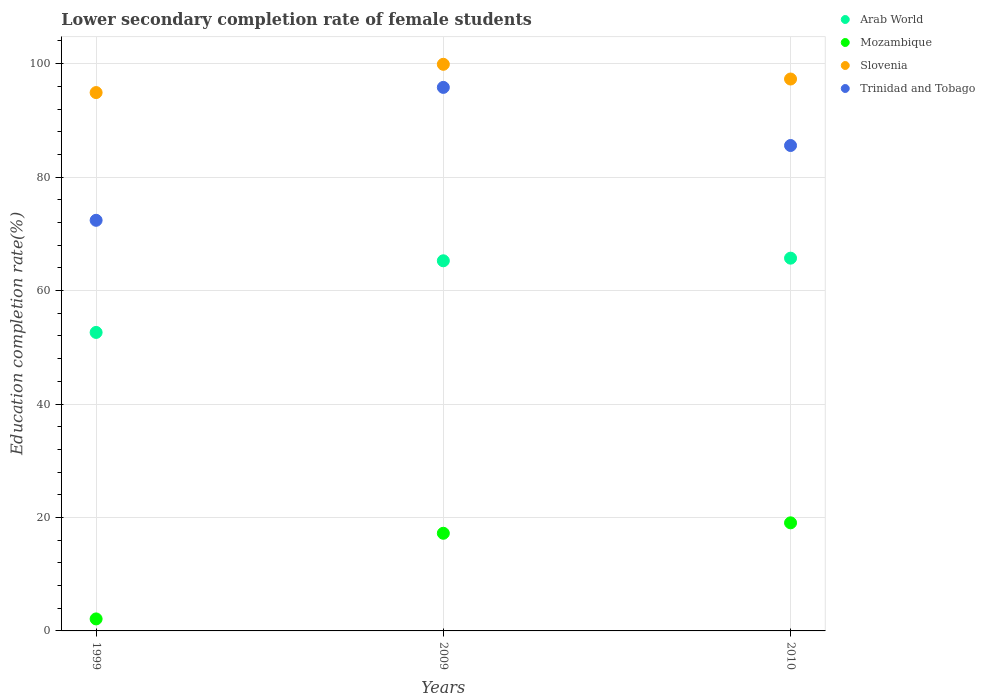How many different coloured dotlines are there?
Provide a succinct answer. 4. What is the lower secondary completion rate of female students in Slovenia in 1999?
Provide a succinct answer. 94.9. Across all years, what is the maximum lower secondary completion rate of female students in Arab World?
Provide a succinct answer. 65.71. Across all years, what is the minimum lower secondary completion rate of female students in Mozambique?
Ensure brevity in your answer.  2.12. In which year was the lower secondary completion rate of female students in Trinidad and Tobago minimum?
Offer a very short reply. 1999. What is the total lower secondary completion rate of female students in Arab World in the graph?
Provide a short and direct response. 183.58. What is the difference between the lower secondary completion rate of female students in Slovenia in 1999 and that in 2009?
Your response must be concise. -4.98. What is the difference between the lower secondary completion rate of female students in Trinidad and Tobago in 1999 and the lower secondary completion rate of female students in Mozambique in 2009?
Keep it short and to the point. 55.17. What is the average lower secondary completion rate of female students in Arab World per year?
Your response must be concise. 61.19. In the year 2010, what is the difference between the lower secondary completion rate of female students in Slovenia and lower secondary completion rate of female students in Trinidad and Tobago?
Your answer should be very brief. 11.72. In how many years, is the lower secondary completion rate of female students in Slovenia greater than 56 %?
Your answer should be compact. 3. What is the ratio of the lower secondary completion rate of female students in Arab World in 2009 to that in 2010?
Your answer should be very brief. 0.99. What is the difference between the highest and the second highest lower secondary completion rate of female students in Slovenia?
Offer a terse response. 2.59. What is the difference between the highest and the lowest lower secondary completion rate of female students in Slovenia?
Your answer should be very brief. 4.98. In how many years, is the lower secondary completion rate of female students in Trinidad and Tobago greater than the average lower secondary completion rate of female students in Trinidad and Tobago taken over all years?
Offer a terse response. 2. Is the sum of the lower secondary completion rate of female students in Trinidad and Tobago in 2009 and 2010 greater than the maximum lower secondary completion rate of female students in Arab World across all years?
Give a very brief answer. Yes. Is the lower secondary completion rate of female students in Slovenia strictly less than the lower secondary completion rate of female students in Arab World over the years?
Provide a short and direct response. No. How many years are there in the graph?
Your answer should be very brief. 3. How many legend labels are there?
Provide a succinct answer. 4. How are the legend labels stacked?
Give a very brief answer. Vertical. What is the title of the graph?
Give a very brief answer. Lower secondary completion rate of female students. What is the label or title of the Y-axis?
Your answer should be compact. Education completion rate(%). What is the Education completion rate(%) of Arab World in 1999?
Make the answer very short. 52.62. What is the Education completion rate(%) of Mozambique in 1999?
Offer a terse response. 2.12. What is the Education completion rate(%) in Slovenia in 1999?
Make the answer very short. 94.9. What is the Education completion rate(%) in Trinidad and Tobago in 1999?
Keep it short and to the point. 72.39. What is the Education completion rate(%) in Arab World in 2009?
Your answer should be compact. 65.25. What is the Education completion rate(%) of Mozambique in 2009?
Your answer should be compact. 17.21. What is the Education completion rate(%) of Slovenia in 2009?
Your answer should be very brief. 99.89. What is the Education completion rate(%) of Trinidad and Tobago in 2009?
Offer a terse response. 95.82. What is the Education completion rate(%) in Arab World in 2010?
Offer a very short reply. 65.71. What is the Education completion rate(%) in Mozambique in 2010?
Keep it short and to the point. 19.05. What is the Education completion rate(%) in Slovenia in 2010?
Your response must be concise. 97.29. What is the Education completion rate(%) of Trinidad and Tobago in 2010?
Keep it short and to the point. 85.57. Across all years, what is the maximum Education completion rate(%) of Arab World?
Give a very brief answer. 65.71. Across all years, what is the maximum Education completion rate(%) of Mozambique?
Ensure brevity in your answer.  19.05. Across all years, what is the maximum Education completion rate(%) of Slovenia?
Give a very brief answer. 99.89. Across all years, what is the maximum Education completion rate(%) in Trinidad and Tobago?
Make the answer very short. 95.82. Across all years, what is the minimum Education completion rate(%) in Arab World?
Give a very brief answer. 52.62. Across all years, what is the minimum Education completion rate(%) of Mozambique?
Your answer should be compact. 2.12. Across all years, what is the minimum Education completion rate(%) of Slovenia?
Your answer should be compact. 94.9. Across all years, what is the minimum Education completion rate(%) of Trinidad and Tobago?
Keep it short and to the point. 72.39. What is the total Education completion rate(%) in Arab World in the graph?
Provide a succinct answer. 183.58. What is the total Education completion rate(%) of Mozambique in the graph?
Give a very brief answer. 38.38. What is the total Education completion rate(%) of Slovenia in the graph?
Give a very brief answer. 292.08. What is the total Education completion rate(%) in Trinidad and Tobago in the graph?
Your response must be concise. 253.77. What is the difference between the Education completion rate(%) in Arab World in 1999 and that in 2009?
Give a very brief answer. -12.63. What is the difference between the Education completion rate(%) in Mozambique in 1999 and that in 2009?
Your answer should be compact. -15.1. What is the difference between the Education completion rate(%) in Slovenia in 1999 and that in 2009?
Your answer should be very brief. -4.98. What is the difference between the Education completion rate(%) of Trinidad and Tobago in 1999 and that in 2009?
Your response must be concise. -23.43. What is the difference between the Education completion rate(%) in Arab World in 1999 and that in 2010?
Your response must be concise. -13.09. What is the difference between the Education completion rate(%) in Mozambique in 1999 and that in 2010?
Make the answer very short. -16.94. What is the difference between the Education completion rate(%) of Slovenia in 1999 and that in 2010?
Ensure brevity in your answer.  -2.39. What is the difference between the Education completion rate(%) of Trinidad and Tobago in 1999 and that in 2010?
Your answer should be very brief. -13.19. What is the difference between the Education completion rate(%) of Arab World in 2009 and that in 2010?
Your answer should be compact. -0.46. What is the difference between the Education completion rate(%) of Mozambique in 2009 and that in 2010?
Provide a succinct answer. -1.84. What is the difference between the Education completion rate(%) in Slovenia in 2009 and that in 2010?
Give a very brief answer. 2.59. What is the difference between the Education completion rate(%) in Trinidad and Tobago in 2009 and that in 2010?
Your answer should be very brief. 10.24. What is the difference between the Education completion rate(%) in Arab World in 1999 and the Education completion rate(%) in Mozambique in 2009?
Keep it short and to the point. 35.41. What is the difference between the Education completion rate(%) in Arab World in 1999 and the Education completion rate(%) in Slovenia in 2009?
Your answer should be very brief. -47.27. What is the difference between the Education completion rate(%) in Arab World in 1999 and the Education completion rate(%) in Trinidad and Tobago in 2009?
Ensure brevity in your answer.  -43.2. What is the difference between the Education completion rate(%) of Mozambique in 1999 and the Education completion rate(%) of Slovenia in 2009?
Keep it short and to the point. -97.77. What is the difference between the Education completion rate(%) in Mozambique in 1999 and the Education completion rate(%) in Trinidad and Tobago in 2009?
Offer a terse response. -93.7. What is the difference between the Education completion rate(%) in Slovenia in 1999 and the Education completion rate(%) in Trinidad and Tobago in 2009?
Provide a short and direct response. -0.91. What is the difference between the Education completion rate(%) in Arab World in 1999 and the Education completion rate(%) in Mozambique in 2010?
Offer a terse response. 33.57. What is the difference between the Education completion rate(%) of Arab World in 1999 and the Education completion rate(%) of Slovenia in 2010?
Give a very brief answer. -44.67. What is the difference between the Education completion rate(%) in Arab World in 1999 and the Education completion rate(%) in Trinidad and Tobago in 2010?
Ensure brevity in your answer.  -32.95. What is the difference between the Education completion rate(%) of Mozambique in 1999 and the Education completion rate(%) of Slovenia in 2010?
Offer a very short reply. -95.17. What is the difference between the Education completion rate(%) in Mozambique in 1999 and the Education completion rate(%) in Trinidad and Tobago in 2010?
Give a very brief answer. -83.45. What is the difference between the Education completion rate(%) in Slovenia in 1999 and the Education completion rate(%) in Trinidad and Tobago in 2010?
Provide a short and direct response. 9.33. What is the difference between the Education completion rate(%) of Arab World in 2009 and the Education completion rate(%) of Mozambique in 2010?
Your answer should be very brief. 46.2. What is the difference between the Education completion rate(%) of Arab World in 2009 and the Education completion rate(%) of Slovenia in 2010?
Your response must be concise. -32.04. What is the difference between the Education completion rate(%) in Arab World in 2009 and the Education completion rate(%) in Trinidad and Tobago in 2010?
Ensure brevity in your answer.  -20.32. What is the difference between the Education completion rate(%) of Mozambique in 2009 and the Education completion rate(%) of Slovenia in 2010?
Your response must be concise. -80.08. What is the difference between the Education completion rate(%) of Mozambique in 2009 and the Education completion rate(%) of Trinidad and Tobago in 2010?
Offer a very short reply. -68.36. What is the difference between the Education completion rate(%) of Slovenia in 2009 and the Education completion rate(%) of Trinidad and Tobago in 2010?
Offer a very short reply. 14.32. What is the average Education completion rate(%) in Arab World per year?
Your answer should be compact. 61.19. What is the average Education completion rate(%) in Mozambique per year?
Offer a very short reply. 12.79. What is the average Education completion rate(%) of Slovenia per year?
Offer a very short reply. 97.36. What is the average Education completion rate(%) in Trinidad and Tobago per year?
Provide a succinct answer. 84.59. In the year 1999, what is the difference between the Education completion rate(%) in Arab World and Education completion rate(%) in Mozambique?
Keep it short and to the point. 50.5. In the year 1999, what is the difference between the Education completion rate(%) of Arab World and Education completion rate(%) of Slovenia?
Offer a terse response. -42.28. In the year 1999, what is the difference between the Education completion rate(%) of Arab World and Education completion rate(%) of Trinidad and Tobago?
Offer a very short reply. -19.77. In the year 1999, what is the difference between the Education completion rate(%) in Mozambique and Education completion rate(%) in Slovenia?
Your answer should be very brief. -92.79. In the year 1999, what is the difference between the Education completion rate(%) of Mozambique and Education completion rate(%) of Trinidad and Tobago?
Keep it short and to the point. -70.27. In the year 1999, what is the difference between the Education completion rate(%) of Slovenia and Education completion rate(%) of Trinidad and Tobago?
Offer a very short reply. 22.52. In the year 2009, what is the difference between the Education completion rate(%) in Arab World and Education completion rate(%) in Mozambique?
Your answer should be very brief. 48.04. In the year 2009, what is the difference between the Education completion rate(%) of Arab World and Education completion rate(%) of Slovenia?
Your response must be concise. -34.64. In the year 2009, what is the difference between the Education completion rate(%) in Arab World and Education completion rate(%) in Trinidad and Tobago?
Keep it short and to the point. -30.57. In the year 2009, what is the difference between the Education completion rate(%) in Mozambique and Education completion rate(%) in Slovenia?
Offer a terse response. -82.67. In the year 2009, what is the difference between the Education completion rate(%) of Mozambique and Education completion rate(%) of Trinidad and Tobago?
Your answer should be compact. -78.6. In the year 2009, what is the difference between the Education completion rate(%) of Slovenia and Education completion rate(%) of Trinidad and Tobago?
Provide a short and direct response. 4.07. In the year 2010, what is the difference between the Education completion rate(%) in Arab World and Education completion rate(%) in Mozambique?
Ensure brevity in your answer.  46.66. In the year 2010, what is the difference between the Education completion rate(%) in Arab World and Education completion rate(%) in Slovenia?
Your answer should be very brief. -31.58. In the year 2010, what is the difference between the Education completion rate(%) in Arab World and Education completion rate(%) in Trinidad and Tobago?
Provide a short and direct response. -19.86. In the year 2010, what is the difference between the Education completion rate(%) of Mozambique and Education completion rate(%) of Slovenia?
Your answer should be very brief. -78.24. In the year 2010, what is the difference between the Education completion rate(%) in Mozambique and Education completion rate(%) in Trinidad and Tobago?
Keep it short and to the point. -66.52. In the year 2010, what is the difference between the Education completion rate(%) of Slovenia and Education completion rate(%) of Trinidad and Tobago?
Make the answer very short. 11.72. What is the ratio of the Education completion rate(%) of Arab World in 1999 to that in 2009?
Provide a short and direct response. 0.81. What is the ratio of the Education completion rate(%) in Mozambique in 1999 to that in 2009?
Keep it short and to the point. 0.12. What is the ratio of the Education completion rate(%) in Slovenia in 1999 to that in 2009?
Your answer should be very brief. 0.95. What is the ratio of the Education completion rate(%) of Trinidad and Tobago in 1999 to that in 2009?
Ensure brevity in your answer.  0.76. What is the ratio of the Education completion rate(%) of Arab World in 1999 to that in 2010?
Your answer should be very brief. 0.8. What is the ratio of the Education completion rate(%) of Slovenia in 1999 to that in 2010?
Keep it short and to the point. 0.98. What is the ratio of the Education completion rate(%) in Trinidad and Tobago in 1999 to that in 2010?
Keep it short and to the point. 0.85. What is the ratio of the Education completion rate(%) in Arab World in 2009 to that in 2010?
Ensure brevity in your answer.  0.99. What is the ratio of the Education completion rate(%) in Mozambique in 2009 to that in 2010?
Your answer should be very brief. 0.9. What is the ratio of the Education completion rate(%) in Slovenia in 2009 to that in 2010?
Provide a succinct answer. 1.03. What is the ratio of the Education completion rate(%) in Trinidad and Tobago in 2009 to that in 2010?
Keep it short and to the point. 1.12. What is the difference between the highest and the second highest Education completion rate(%) in Arab World?
Make the answer very short. 0.46. What is the difference between the highest and the second highest Education completion rate(%) of Mozambique?
Provide a short and direct response. 1.84. What is the difference between the highest and the second highest Education completion rate(%) of Slovenia?
Offer a terse response. 2.59. What is the difference between the highest and the second highest Education completion rate(%) of Trinidad and Tobago?
Provide a short and direct response. 10.24. What is the difference between the highest and the lowest Education completion rate(%) of Arab World?
Your answer should be compact. 13.09. What is the difference between the highest and the lowest Education completion rate(%) in Mozambique?
Your answer should be compact. 16.94. What is the difference between the highest and the lowest Education completion rate(%) of Slovenia?
Provide a short and direct response. 4.98. What is the difference between the highest and the lowest Education completion rate(%) of Trinidad and Tobago?
Ensure brevity in your answer.  23.43. 